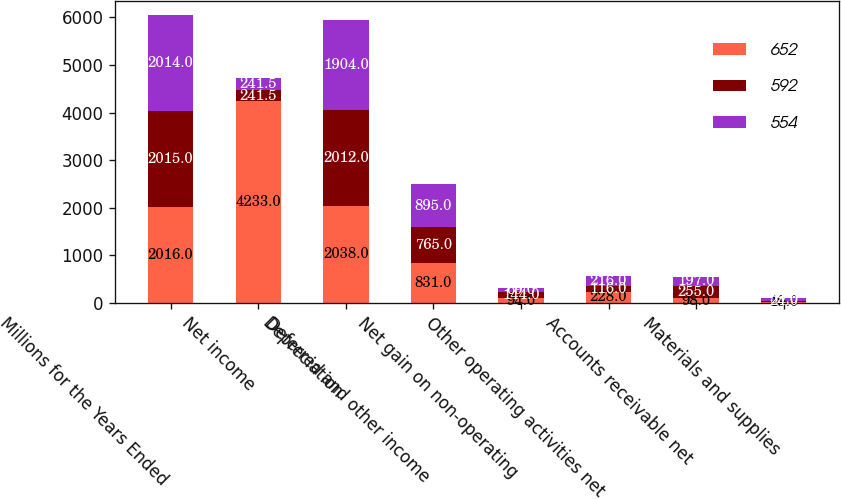Convert chart to OTSL. <chart><loc_0><loc_0><loc_500><loc_500><stacked_bar_chart><ecel><fcel>Millions for the Years Ended<fcel>Net income<fcel>Depreciation<fcel>Deferred and other income<fcel>Net gain on non-operating<fcel>Other operating activities net<fcel>Accounts receivable net<fcel>Materials and supplies<nl><fcel>652<fcel>2016<fcel>4233<fcel>2038<fcel>831<fcel>94<fcel>228<fcel>98<fcel>19<nl><fcel>592<fcel>2015<fcel>241.5<fcel>2012<fcel>765<fcel>144<fcel>116<fcel>255<fcel>24<nl><fcel>554<fcel>2014<fcel>241.5<fcel>1904<fcel>895<fcel>69<fcel>216<fcel>197<fcel>59<nl></chart> 